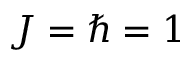<formula> <loc_0><loc_0><loc_500><loc_500>J = \hbar { = } 1</formula> 